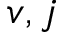<formula> <loc_0><loc_0><loc_500><loc_500>v , j</formula> 